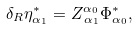Convert formula to latex. <formula><loc_0><loc_0><loc_500><loc_500>\delta _ { R } \eta _ { \alpha _ { 1 } } ^ { * } = Z _ { \, \alpha _ { 1 } } ^ { \alpha _ { 0 } } \Phi _ { \alpha _ { 0 } } ^ { * } ,</formula> 